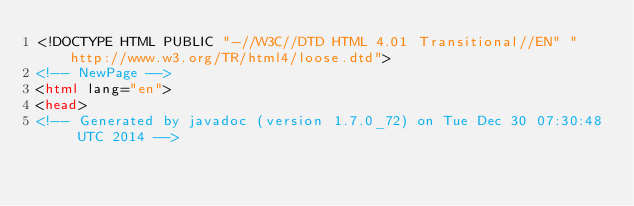Convert code to text. <code><loc_0><loc_0><loc_500><loc_500><_HTML_><!DOCTYPE HTML PUBLIC "-//W3C//DTD HTML 4.01 Transitional//EN" "http://www.w3.org/TR/html4/loose.dtd">
<!-- NewPage -->
<html lang="en">
<head>
<!-- Generated by javadoc (version 1.7.0_72) on Tue Dec 30 07:30:48 UTC 2014 --></code> 